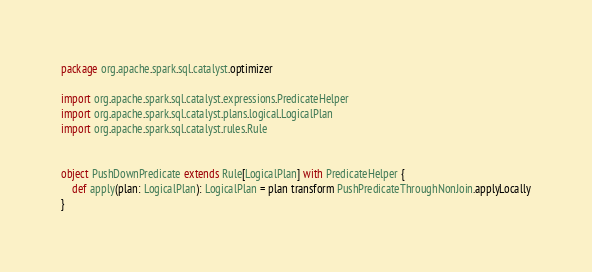<code> <loc_0><loc_0><loc_500><loc_500><_Scala_>package org.apache.spark.sql.catalyst.optimizer

import org.apache.spark.sql.catalyst.expressions.PredicateHelper
import org.apache.spark.sql.catalyst.plans.logical.LogicalPlan
import org.apache.spark.sql.catalyst.rules.Rule


object PushDownPredicate extends Rule[LogicalPlan] with PredicateHelper {
    def apply(plan: LogicalPlan): LogicalPlan = plan transform PushPredicateThroughNonJoin.applyLocally
}
</code> 